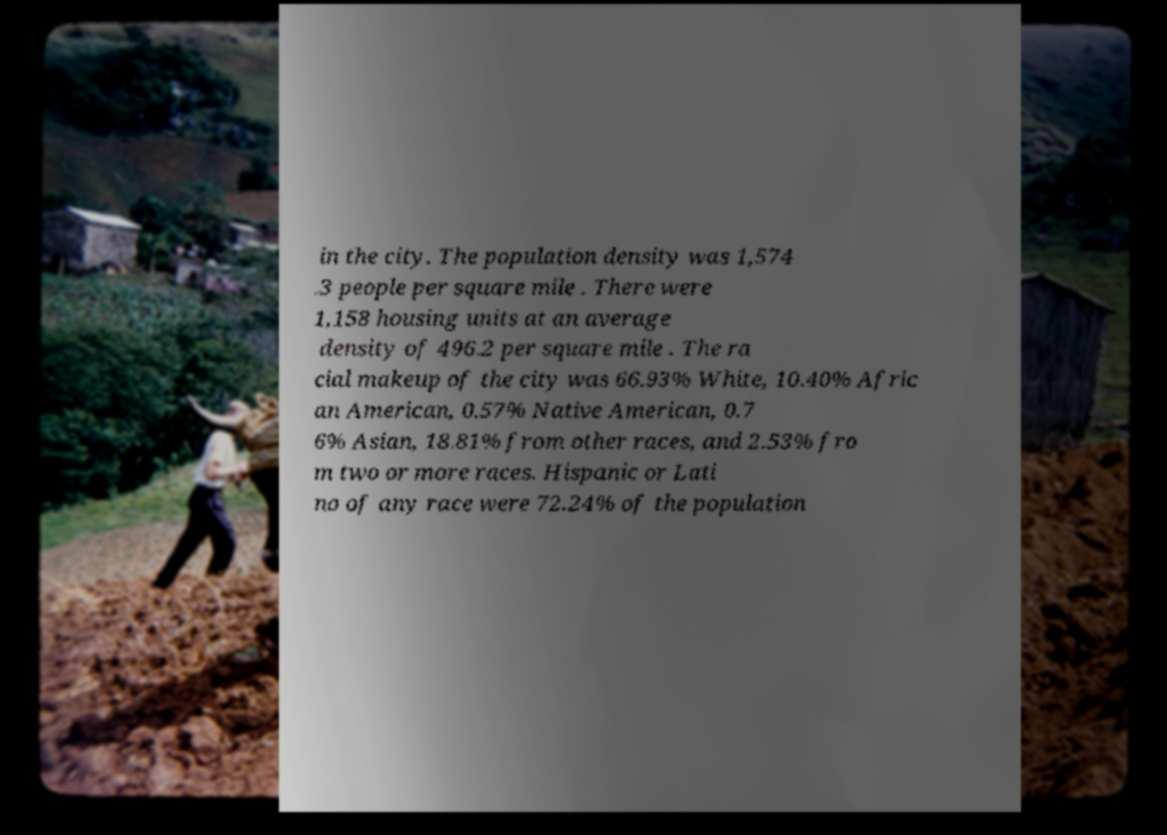Can you read and provide the text displayed in the image?This photo seems to have some interesting text. Can you extract and type it out for me? in the city. The population density was 1,574 .3 people per square mile . There were 1,158 housing units at an average density of 496.2 per square mile . The ra cial makeup of the city was 66.93% White, 10.40% Afric an American, 0.57% Native American, 0.7 6% Asian, 18.81% from other races, and 2.53% fro m two or more races. Hispanic or Lati no of any race were 72.24% of the population 